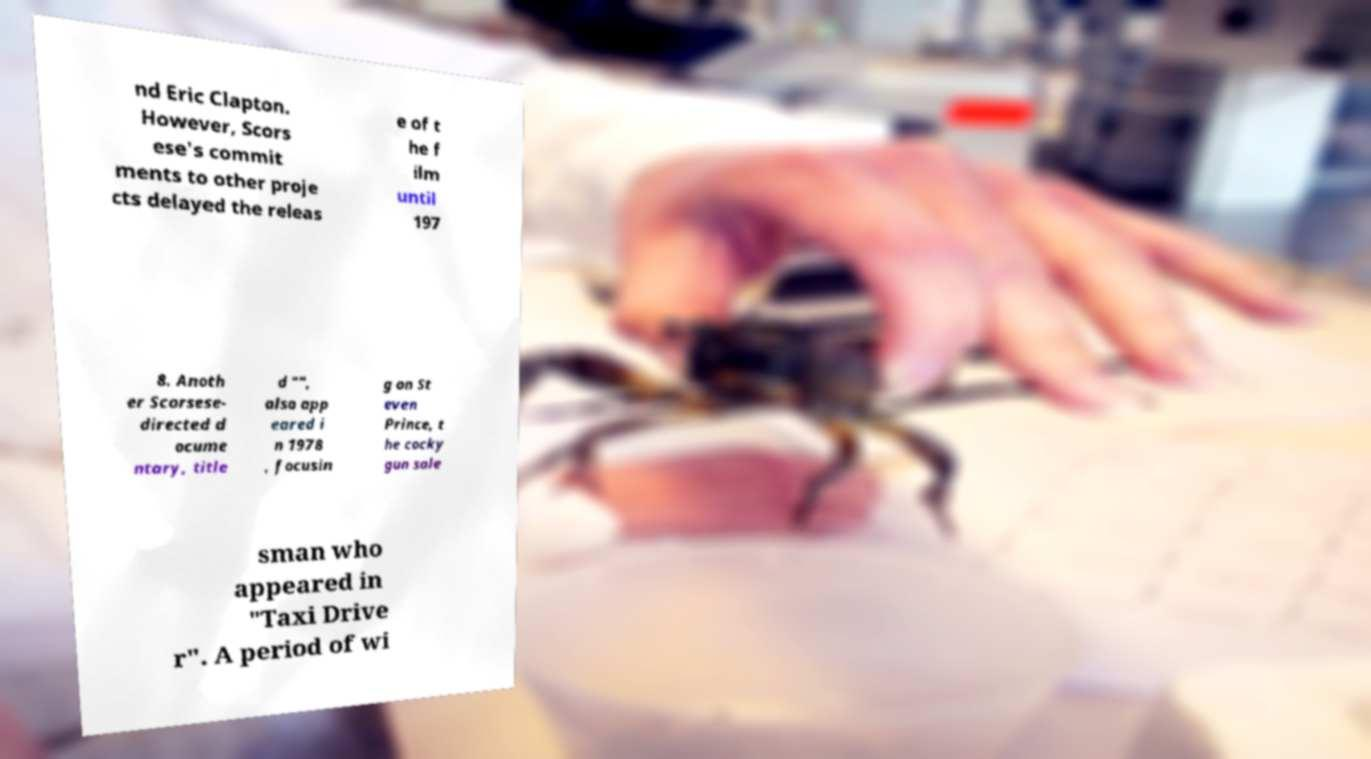What messages or text are displayed in this image? I need them in a readable, typed format. nd Eric Clapton. However, Scors ese's commit ments to other proje cts delayed the releas e of t he f ilm until 197 8. Anoth er Scorsese- directed d ocume ntary, title d "", also app eared i n 1978 , focusin g on St even Prince, t he cocky gun sale sman who appeared in "Taxi Drive r". A period of wi 